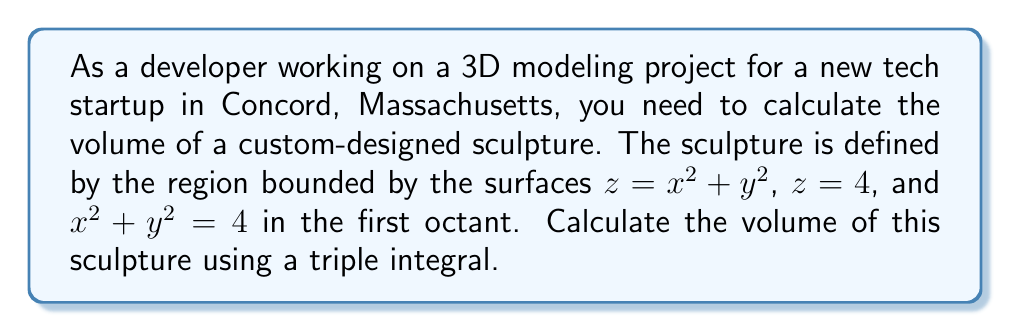Could you help me with this problem? To solve this problem, we'll follow these steps:

1. Identify the bounds of integration:
   The region is in the first octant, so $x \geq 0$, $y \geq 0$, and $z \geq 0$.
   The cylinder $x^2 + y^2 = 4$ gives us the outer bounds for $x$ and $y$.
   The surfaces $z = x^2 + y^2$ and $z = 4$ give us the bounds for $z$.

2. Set up the triple integral:
   $$V = \iiint_V dV = \int_0^2 \int_0^{\sqrt{4-x^2}} \int_{x^2+y^2}^4 dz dy dx$$

3. Evaluate the innermost integral (with respect to $z$):
   $$\int_0^2 \int_0^{\sqrt{4-x^2}} [z]_{x^2+y^2}^4 dy dx$$
   $$= \int_0^2 \int_0^{\sqrt{4-x^2}} (4 - (x^2+y^2)) dy dx$$

4. Evaluate the middle integral (with respect to $y$):
   $$\int_0^2 \left[4y - xy^2 - \frac{y^3}{3}\right]_0^{\sqrt{4-x^2}} dx$$
   $$= \int_0^2 \left(4\sqrt{4-x^2} - x(4-x^2) - \frac{(4-x^2)^{3/2}}{3}\right) dx$$

5. Evaluate the outer integral (with respect to $x$):
   This step involves complex integration. We can use substitution $x = 2\sin\theta$ to simplify:
   $$\int_0^{\pi/2} \left(8\cos\theta - 8\sin\theta\cos^2\theta - \frac{8}{3}\cos^3\theta\right) 2\cos\theta d\theta$$
   $$= 16\int_0^{\pi/2} (\cos^2\theta - \sin\theta\cos^3\theta - \frac{1}{3}\cos^4\theta) d\theta$$

6. Evaluate this integral:
   $$16\left[\frac{\theta}{2} + \frac{\sin\theta\cos\theta}{2} + \frac{\sin\theta\cos^3\theta}{12} - \frac{1}{3}\left(\frac{3\theta}{8} + \frac{\sin2\theta}{4} + \frac{\sin4\theta}{32}\right)\right]_0^{\pi/2}$$

7. Simplify and calculate the final result:
   $$16\left(\frac{\pi}{4} - \frac{\pi}{8}\right) = 16 \cdot \frac{\pi}{8} = 2\pi$$

Thus, the volume of the sculpture is $2\pi$ cubic units.
Answer: $2\pi$ cubic units 